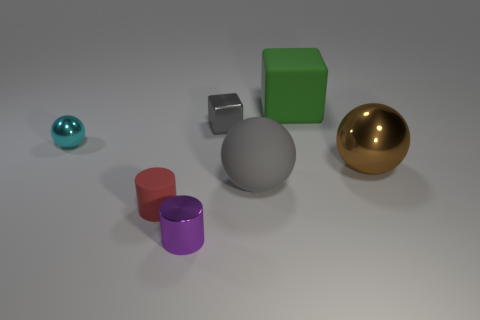The large object that is the same color as the tiny block is what shape?
Your answer should be compact. Sphere. What is the size of the thing that is the same color as the metal cube?
Give a very brief answer. Large. The tiny metal object that is both on the left side of the tiny gray metallic object and behind the small purple shiny cylinder is what color?
Keep it short and to the point. Cyan. Do the shiny object that is in front of the red rubber cylinder and the big cube have the same color?
Your answer should be very brief. No. What number of cubes are either large purple rubber things or green rubber objects?
Your answer should be very brief. 1. There is a large rubber thing that is to the right of the big rubber ball; what is its shape?
Your response must be concise. Cube. There is a object to the left of the tiny red rubber thing that is behind the tiny metallic object in front of the cyan ball; what color is it?
Keep it short and to the point. Cyan. Does the red cylinder have the same material as the big gray sphere?
Offer a very short reply. Yes. What number of cyan things are either cylinders or cubes?
Ensure brevity in your answer.  0. There is a tiny shiny ball; how many tiny gray metal objects are to the right of it?
Your answer should be compact. 1. 